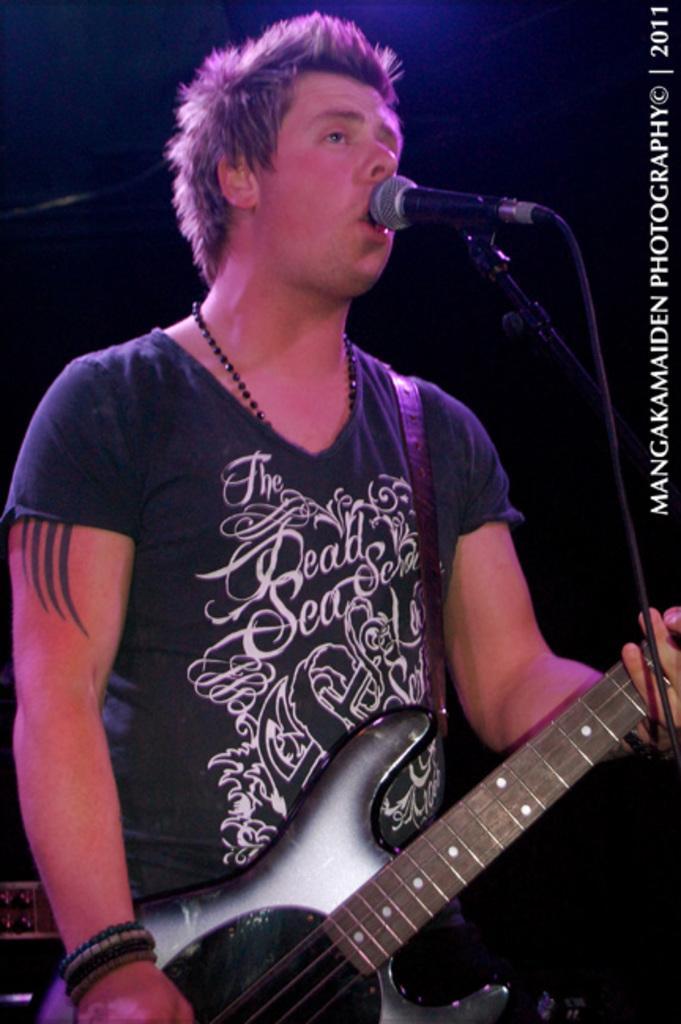How would you summarize this image in a sentence or two? In this image I can see a man is holding a guitar. Here I can see a mic in front of him. 